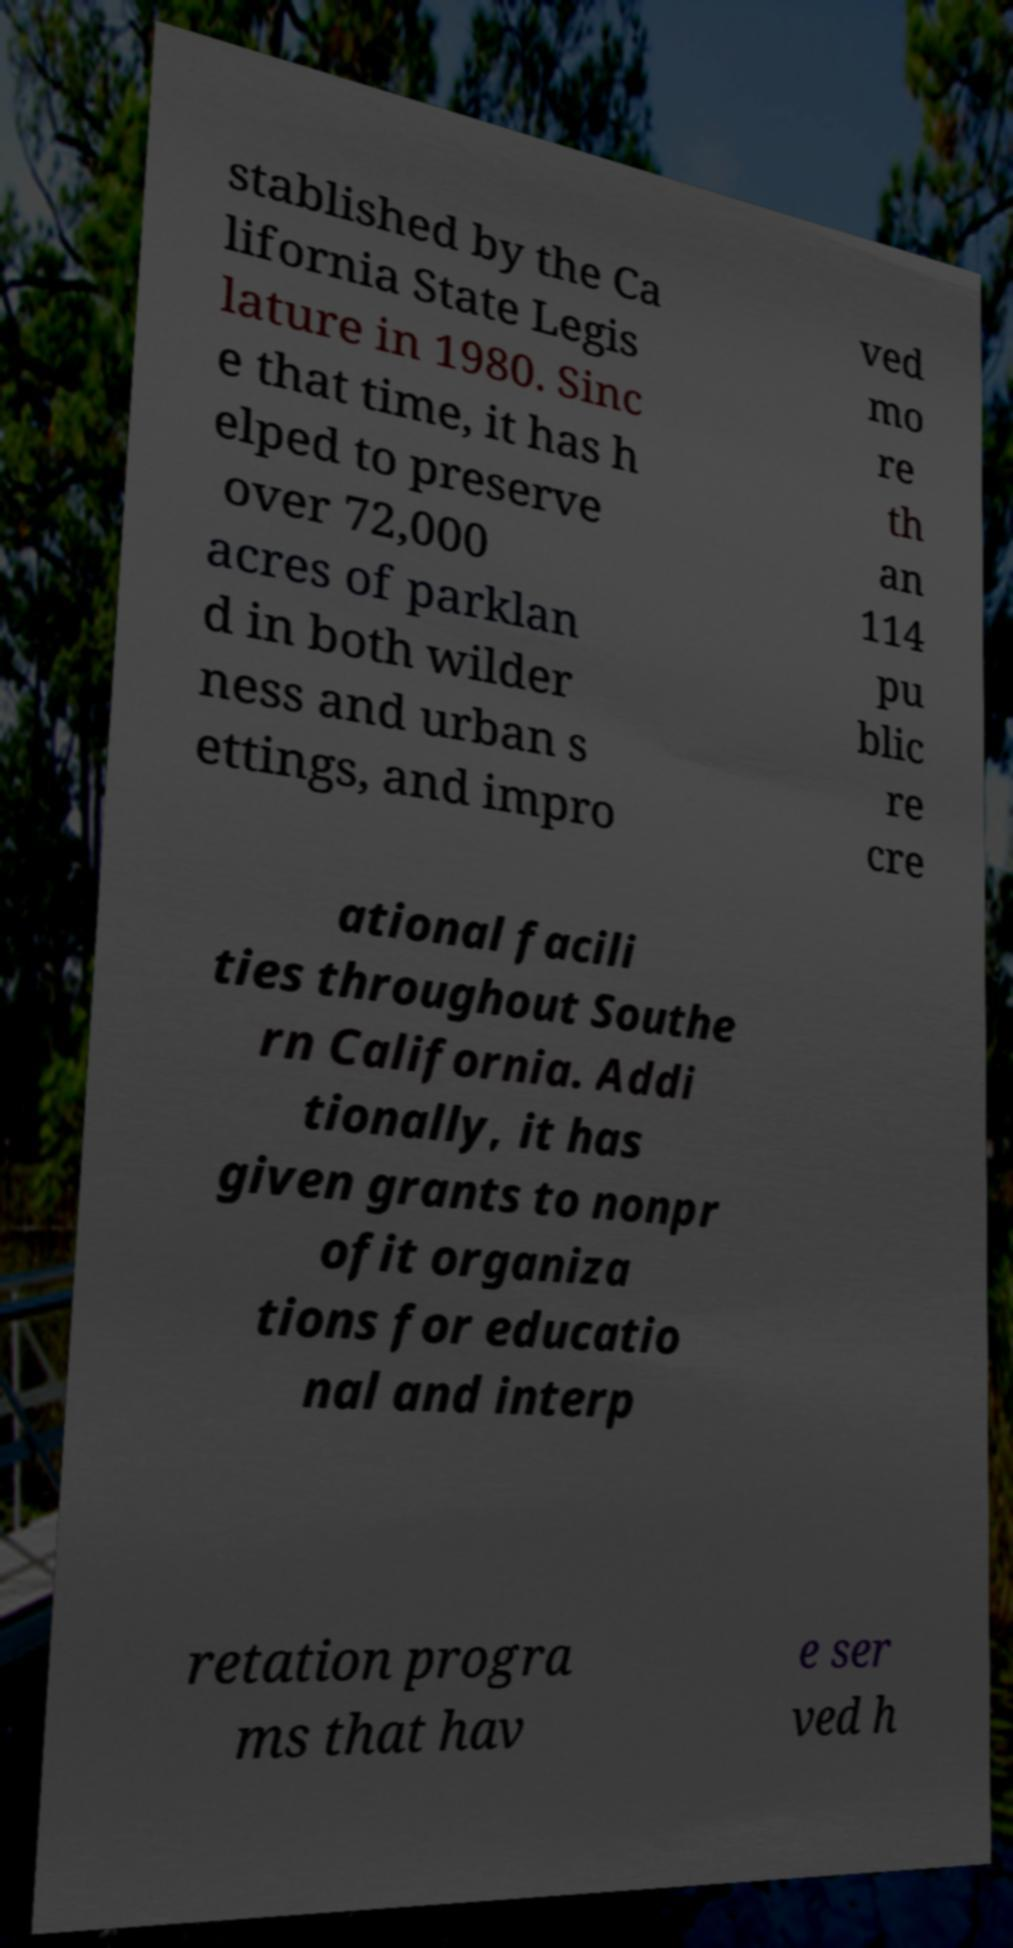Please read and relay the text visible in this image. What does it say? stablished by the Ca lifornia State Legis lature in 1980. Sinc e that time, it has h elped to preserve over 72,000 acres of parklan d in both wilder ness and urban s ettings, and impro ved mo re th an 114 pu blic re cre ational facili ties throughout Southe rn California. Addi tionally, it has given grants to nonpr ofit organiza tions for educatio nal and interp retation progra ms that hav e ser ved h 